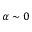<formula> <loc_0><loc_0><loc_500><loc_500>\alpha \sim 0</formula> 